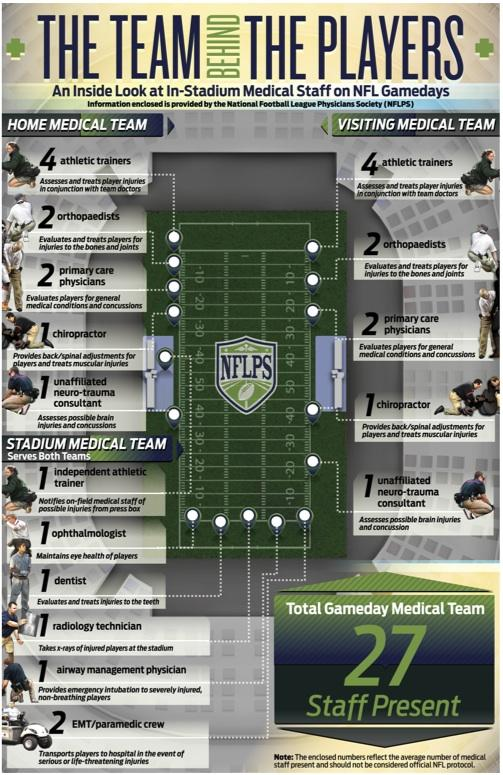Identify some key points in this picture. The unaffiliated neuro-trauma consultant will have access to possible brain injuries and concussions of players on NFL game-days. According to the NFLPS, there will be two primary care physicians in the home medical team. On NFL game-days, a home medical team consists of 10 medical staff members, who provide essential care and support to players throughout the game. There are seven medical staff members who serve on the stadium medical team for NFL game-days. According to the NFLPS, the total number of medical staff present on an NFL game-day is 27. 